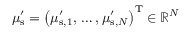Convert formula to latex. <formula><loc_0><loc_0><loc_500><loc_500>\mu _ { s } ^ { \prime } = \left ( \mu _ { s , 1 } ^ { \prime } , \, \dots , \mu _ { s , N } ^ { \prime } \right ) ^ { T } \in \mathbb { R } ^ { N }</formula> 